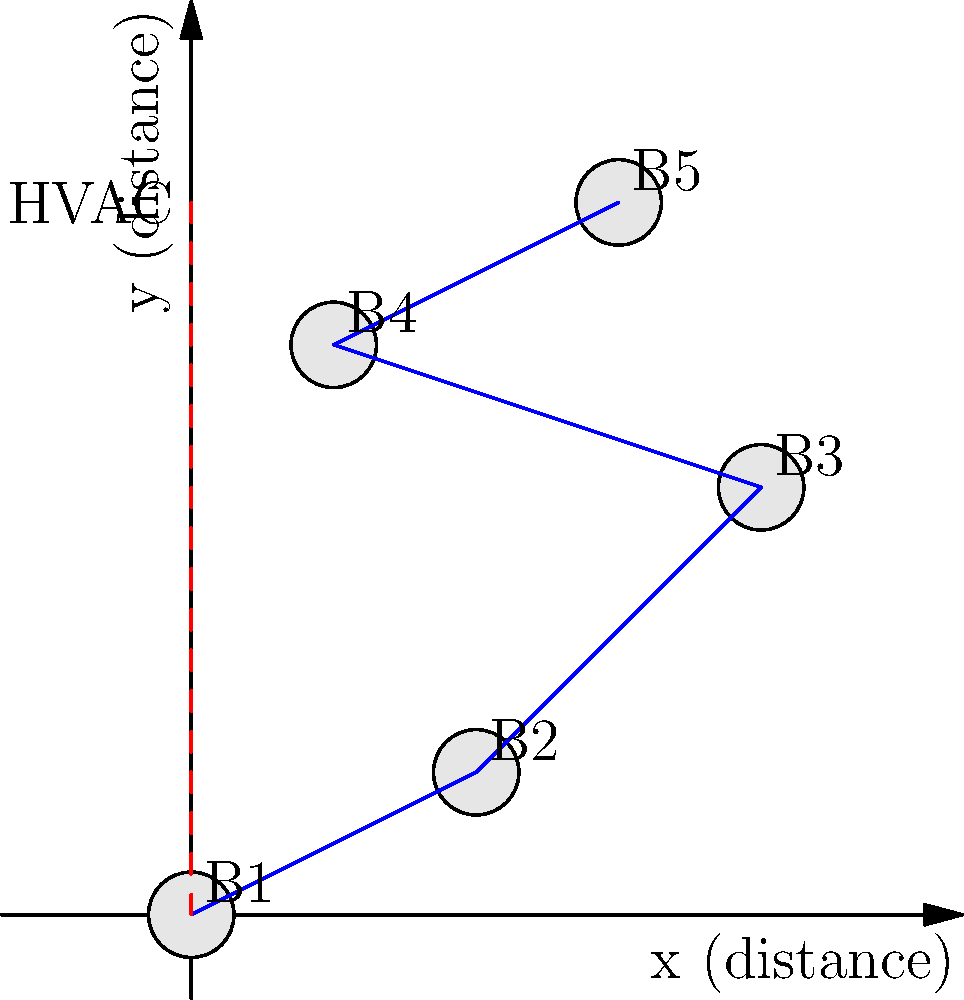In designing an energy-efficient HVAC system layout for a multi-building resort, you need to minimize the total length of ductwork connecting all buildings to the central HVAC unit. Given the positions of 5 buildings (B1 to B5) in a 2D plane as shown in the diagram, what is the optimal layout to connect all buildings, and what is the total length of ductwork required? To find the optimal layout and minimum total length of ductwork, we need to use the concept of Minimum Spanning Tree (MST). Here's how to solve this problem step-by-step:

1. Identify the coordinates of each building:
   B1: (0, 0)
   B2: (2, 1)
   B3: (4, 3)
   B4: (1, 4)
   B5: (3, 5)

2. Calculate the distances between all pairs of buildings using the distance formula:
   $d = \sqrt{(x_2 - x_1)^2 + (y_2 - y_1)^2}$

3. Create a graph where buildings are nodes and distances are edge weights.

4. Apply Kruskal's or Prim's algorithm to find the MST.

5. The resulting MST gives the optimal layout for connecting all buildings.

6. Sum up the distances in the MST to get the total length of ductwork.

After applying the algorithm, we get the following connections:
- B1 to B2: $\sqrt{2^2 + 1^2} = \sqrt{5} \approx 2.24$
- B2 to B3: $\sqrt{2^2 + 2^2} = 2\sqrt{2} \approx 2.83$
- B3 to B5: $\sqrt{1^2 + 2^2} = \sqrt{5} \approx 2.24$
- B4 to B5: $\sqrt{2^2 + 1^2} = \sqrt{5} \approx 2.24$

The total length of ductwork is the sum of these distances:
$L_{total} = \sqrt{5} + 2\sqrt{2} + \sqrt{5} + \sqrt{5} \approx 9.55$ units
Answer: Optimal layout: B1-B2-B3-B5-B4; Total length: $\sqrt{5} + 2\sqrt{2} + \sqrt{5} + \sqrt{5} \approx 9.55$ units 